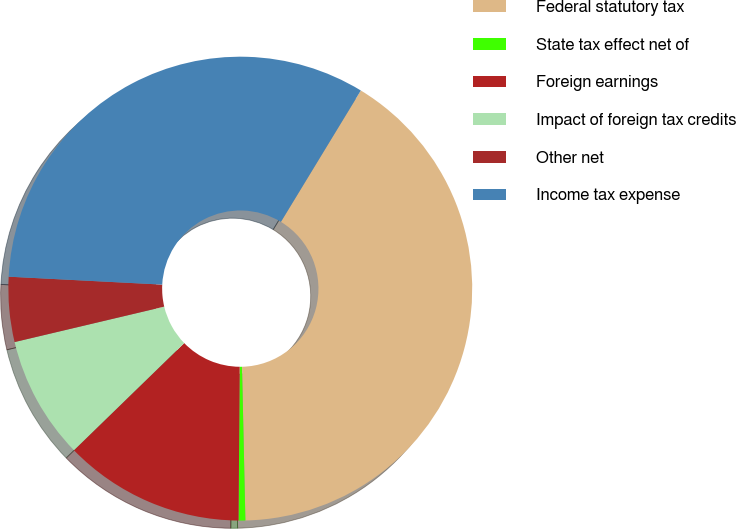<chart> <loc_0><loc_0><loc_500><loc_500><pie_chart><fcel>Federal statutory tax<fcel>State tax effect net of<fcel>Foreign earnings<fcel>Impact of foreign tax credits<fcel>Other net<fcel>Income tax expense<nl><fcel>40.95%<fcel>0.47%<fcel>12.61%<fcel>8.57%<fcel>4.52%<fcel>32.88%<nl></chart> 